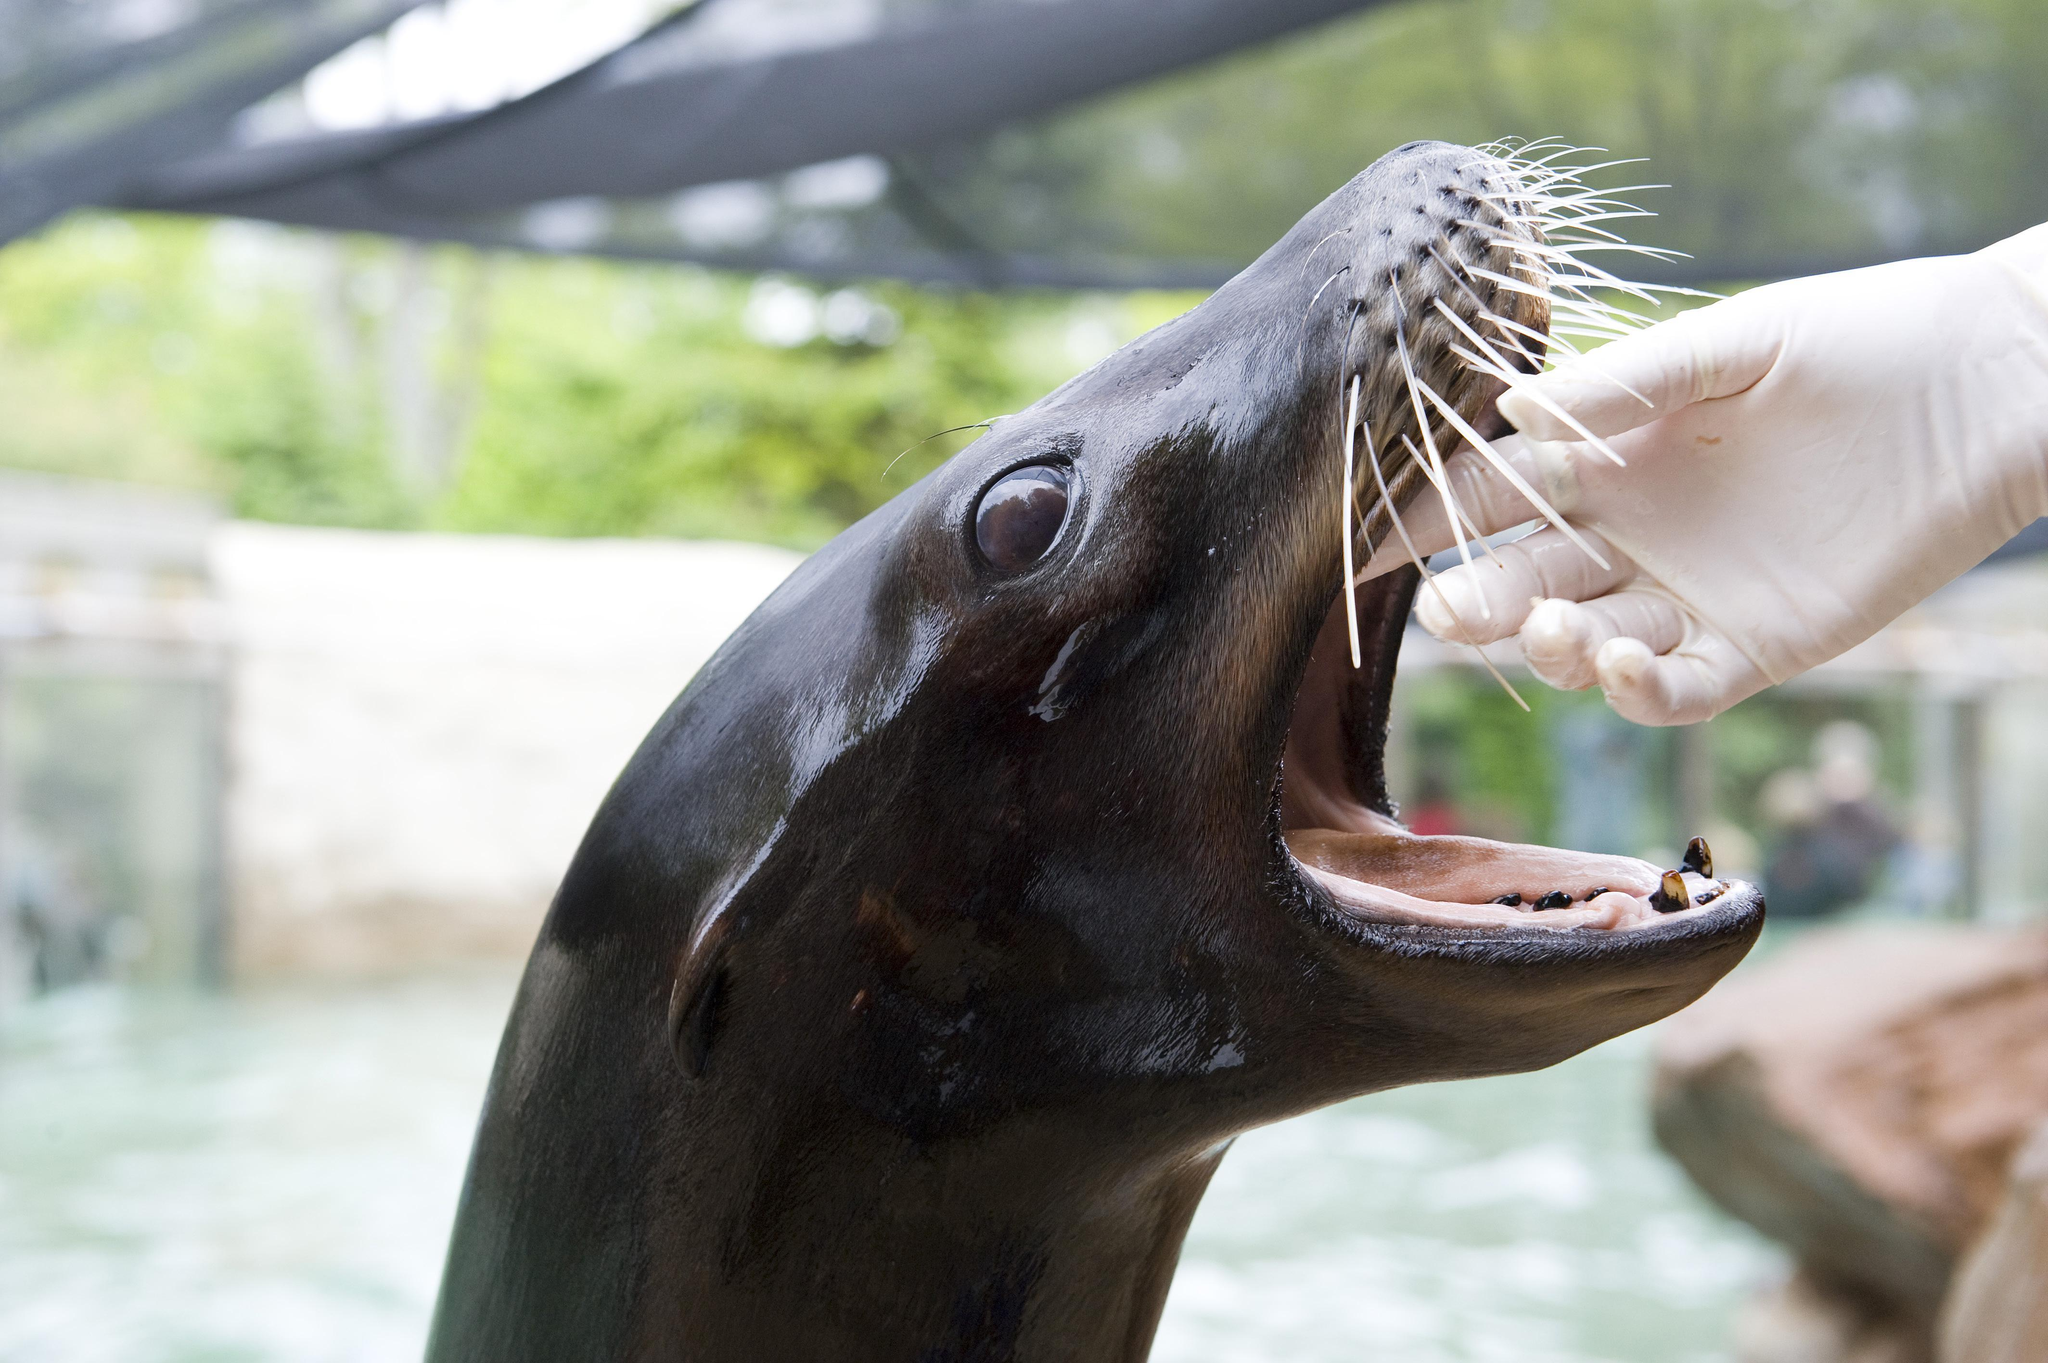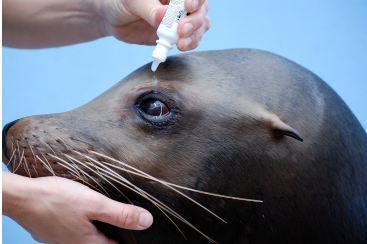The first image is the image on the left, the second image is the image on the right. Analyze the images presented: Is the assertion "At least one image includes human interaction with a seal." valid? Answer yes or no. Yes. 